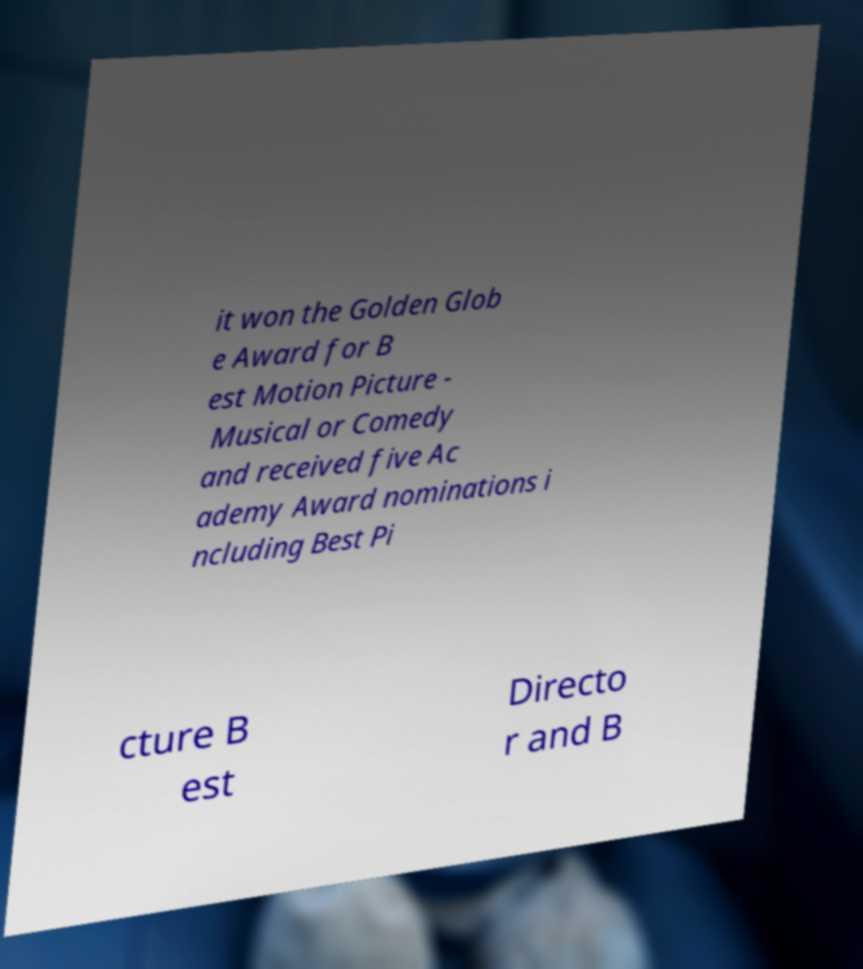There's text embedded in this image that I need extracted. Can you transcribe it verbatim? it won the Golden Glob e Award for B est Motion Picture - Musical or Comedy and received five Ac ademy Award nominations i ncluding Best Pi cture B est Directo r and B 